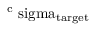Convert formula to latex. <formula><loc_0><loc_0><loc_500><loc_500>^ { c } \ s i g m a _ { \mathrm { t \arg e t } }</formula> 